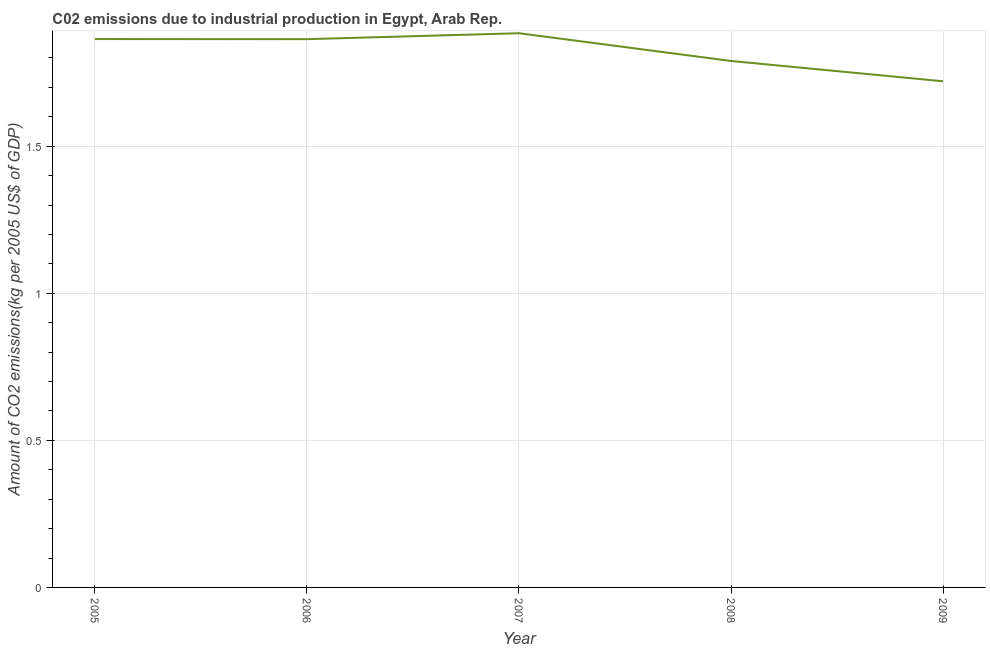What is the amount of co2 emissions in 2009?
Offer a terse response. 1.72. Across all years, what is the maximum amount of co2 emissions?
Offer a terse response. 1.88. Across all years, what is the minimum amount of co2 emissions?
Your answer should be compact. 1.72. In which year was the amount of co2 emissions maximum?
Ensure brevity in your answer.  2007. What is the sum of the amount of co2 emissions?
Make the answer very short. 9.12. What is the difference between the amount of co2 emissions in 2005 and 2006?
Your answer should be very brief. 0. What is the average amount of co2 emissions per year?
Your response must be concise. 1.82. What is the median amount of co2 emissions?
Provide a succinct answer. 1.86. In how many years, is the amount of co2 emissions greater than 1.4 kg per 2005 US$ of GDP?
Offer a very short reply. 5. What is the ratio of the amount of co2 emissions in 2006 to that in 2007?
Offer a terse response. 0.99. What is the difference between the highest and the second highest amount of co2 emissions?
Provide a short and direct response. 0.02. Is the sum of the amount of co2 emissions in 2008 and 2009 greater than the maximum amount of co2 emissions across all years?
Ensure brevity in your answer.  Yes. What is the difference between the highest and the lowest amount of co2 emissions?
Offer a terse response. 0.16. In how many years, is the amount of co2 emissions greater than the average amount of co2 emissions taken over all years?
Provide a short and direct response. 3. Does the amount of co2 emissions monotonically increase over the years?
Make the answer very short. No. How many lines are there?
Make the answer very short. 1. How many years are there in the graph?
Offer a terse response. 5. Does the graph contain any zero values?
Your response must be concise. No. What is the title of the graph?
Offer a terse response. C02 emissions due to industrial production in Egypt, Arab Rep. What is the label or title of the Y-axis?
Provide a short and direct response. Amount of CO2 emissions(kg per 2005 US$ of GDP). What is the Amount of CO2 emissions(kg per 2005 US$ of GDP) of 2005?
Your answer should be very brief. 1.86. What is the Amount of CO2 emissions(kg per 2005 US$ of GDP) in 2006?
Provide a short and direct response. 1.86. What is the Amount of CO2 emissions(kg per 2005 US$ of GDP) of 2007?
Your response must be concise. 1.88. What is the Amount of CO2 emissions(kg per 2005 US$ of GDP) in 2008?
Make the answer very short. 1.79. What is the Amount of CO2 emissions(kg per 2005 US$ of GDP) in 2009?
Give a very brief answer. 1.72. What is the difference between the Amount of CO2 emissions(kg per 2005 US$ of GDP) in 2005 and 2006?
Your answer should be very brief. 0. What is the difference between the Amount of CO2 emissions(kg per 2005 US$ of GDP) in 2005 and 2007?
Offer a terse response. -0.02. What is the difference between the Amount of CO2 emissions(kg per 2005 US$ of GDP) in 2005 and 2008?
Your response must be concise. 0.07. What is the difference between the Amount of CO2 emissions(kg per 2005 US$ of GDP) in 2005 and 2009?
Your response must be concise. 0.14. What is the difference between the Amount of CO2 emissions(kg per 2005 US$ of GDP) in 2006 and 2007?
Make the answer very short. -0.02. What is the difference between the Amount of CO2 emissions(kg per 2005 US$ of GDP) in 2006 and 2008?
Ensure brevity in your answer.  0.07. What is the difference between the Amount of CO2 emissions(kg per 2005 US$ of GDP) in 2006 and 2009?
Your response must be concise. 0.14. What is the difference between the Amount of CO2 emissions(kg per 2005 US$ of GDP) in 2007 and 2008?
Your answer should be compact. 0.09. What is the difference between the Amount of CO2 emissions(kg per 2005 US$ of GDP) in 2007 and 2009?
Give a very brief answer. 0.16. What is the difference between the Amount of CO2 emissions(kg per 2005 US$ of GDP) in 2008 and 2009?
Offer a terse response. 0.07. What is the ratio of the Amount of CO2 emissions(kg per 2005 US$ of GDP) in 2005 to that in 2006?
Your response must be concise. 1. What is the ratio of the Amount of CO2 emissions(kg per 2005 US$ of GDP) in 2005 to that in 2008?
Provide a succinct answer. 1.04. What is the ratio of the Amount of CO2 emissions(kg per 2005 US$ of GDP) in 2005 to that in 2009?
Give a very brief answer. 1.08. What is the ratio of the Amount of CO2 emissions(kg per 2005 US$ of GDP) in 2006 to that in 2007?
Offer a very short reply. 0.99. What is the ratio of the Amount of CO2 emissions(kg per 2005 US$ of GDP) in 2006 to that in 2008?
Keep it short and to the point. 1.04. What is the ratio of the Amount of CO2 emissions(kg per 2005 US$ of GDP) in 2006 to that in 2009?
Give a very brief answer. 1.08. What is the ratio of the Amount of CO2 emissions(kg per 2005 US$ of GDP) in 2007 to that in 2008?
Give a very brief answer. 1.05. What is the ratio of the Amount of CO2 emissions(kg per 2005 US$ of GDP) in 2007 to that in 2009?
Make the answer very short. 1.09. 